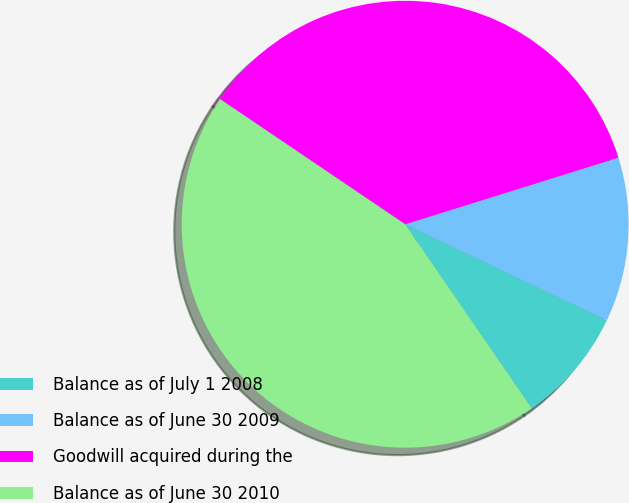Convert chart to OTSL. <chart><loc_0><loc_0><loc_500><loc_500><pie_chart><fcel>Balance as of July 1 2008<fcel>Balance as of June 30 2009<fcel>Goodwill acquired during the<fcel>Balance as of June 30 2010<nl><fcel>8.33%<fcel>11.9%<fcel>35.72%<fcel>44.05%<nl></chart> 